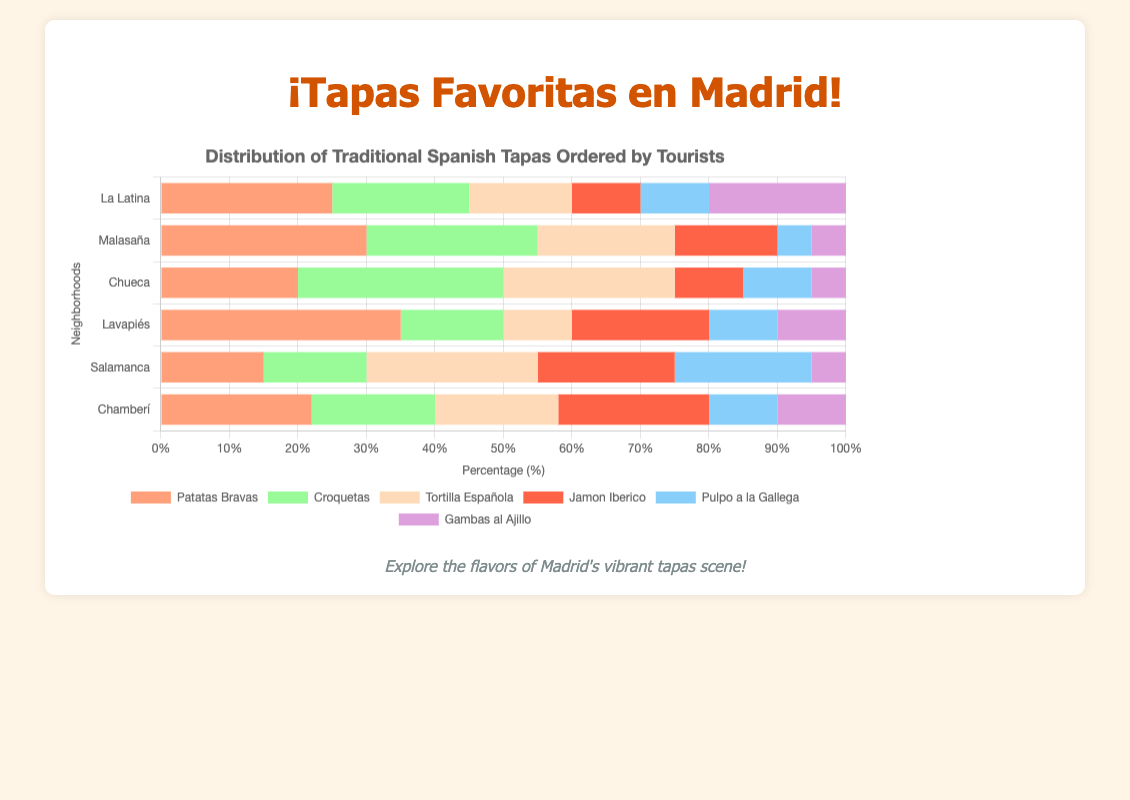Which neighborhood had the highest number of Patatas Bravas ordered? Look at the bar segment for Patatas Bravas, which is colored in orange. Lavapiés shows the longest bar segment for Patatas Bravas.
Answer: Lavapiés Which type of tapas was ordered the least in Malasaña? For Malasaña, compare all the bar segments to see which is the shortest. The shortest segments are for Gambas al Ajillo and Pulpo a la Gallega, each at 5 orders.
Answer: Gambas al Ajillo and Pulpo a la Gallega How many total orders of tortilla española were there in Chueca and Salamanca combined? Look at the bar segment for Tortilla Española in Chueca and Salamanca. Add the numbers: 25 (Chueca) + 25 (Salamanca).
Answer: 50 Which neighborhood had an equal number of Jamon Iberico and Tortilla Española ordered? Compare the lengths of the Jamon Iberico and Tortilla Española bar segments for each neighborhood. In Chamberí, both segments are equally long, each at 22 orders.
Answer: Chamberí Which type of tapas is consistently ordered in all neighborhoods but in lesser quantities in Malasaña and Chueca? Scan each neighborhood for a type of tapas that is present everywhere but has shorter bars in Malasaña and Chueca. Pulpo a la Gallega shows up in all neighborhoods but has lesser quantities in Malasaña (5) and Chueca (10).
Answer: Pulpo a la Gallega What is the total number of tapas ordered in Lavapiés? Sum all types of tapas orders in Lavapiés: 35 (Patatas Bravas) + 15 (Croquetas) + 10 (Tortilla Española) + 20 (Jamon Iberico) + 10 (Pulpo a la Gallega) + 10 (Gambas al Ajillo) = 100.
Answer: 100 Which neighborhood shows the highest variability in the quantities of different tapas ordered? Look for variations in the lengths of bar segments within each neighborhood. Malasaña shows high variability with significant differences between the highest (Patatas Bravas, 30) and the lowest (Pulpo a la Gallega and Gambas al Ajillo, 5).
Answer: Malasaña 